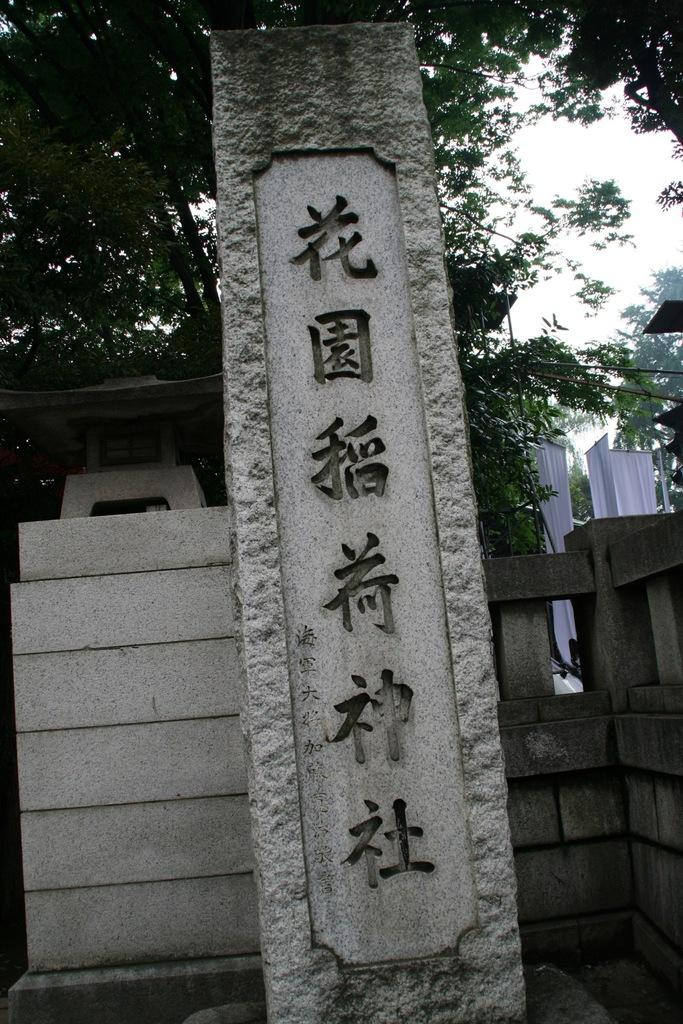What is written on in the image? There is writing on a stone in the image. What can be seen in the background of the image? There is a wall, clothes, trees, and the sky visible in the background of the image. What type of party is being held in the image? There is no party present in the image. Can you describe the sister in the image? There is no sister present in the image. 